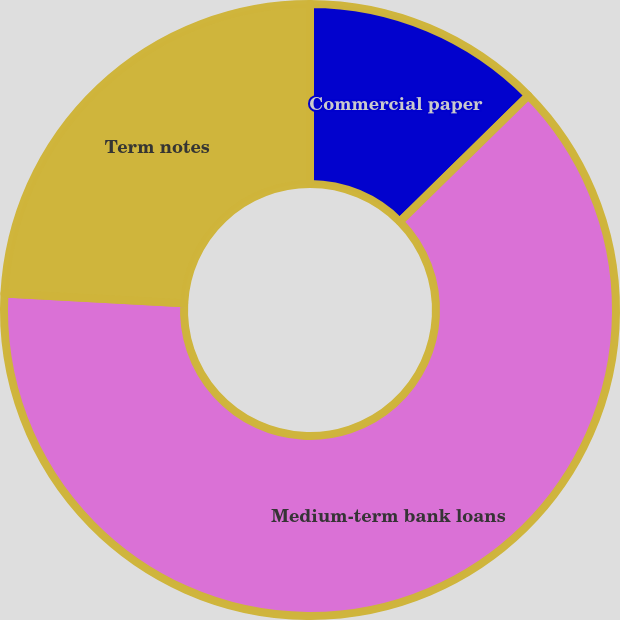<chart> <loc_0><loc_0><loc_500><loc_500><pie_chart><fcel>Commercial paper<fcel>Medium-term bank loans<fcel>Term notes<nl><fcel>12.64%<fcel>63.22%<fcel>24.14%<nl></chart> 